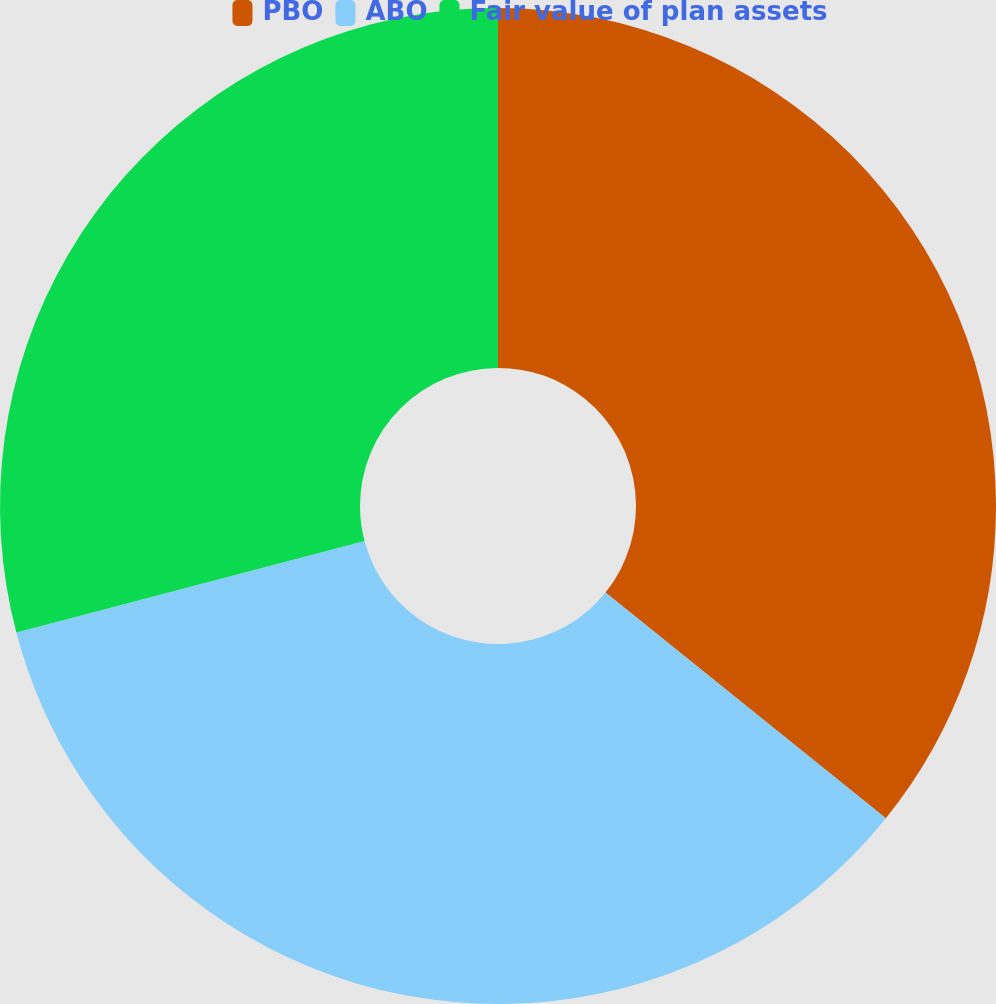Convert chart to OTSL. <chart><loc_0><loc_0><loc_500><loc_500><pie_chart><fcel>PBO<fcel>ABO<fcel>Fair value of plan assets<nl><fcel>35.79%<fcel>35.12%<fcel>29.09%<nl></chart> 